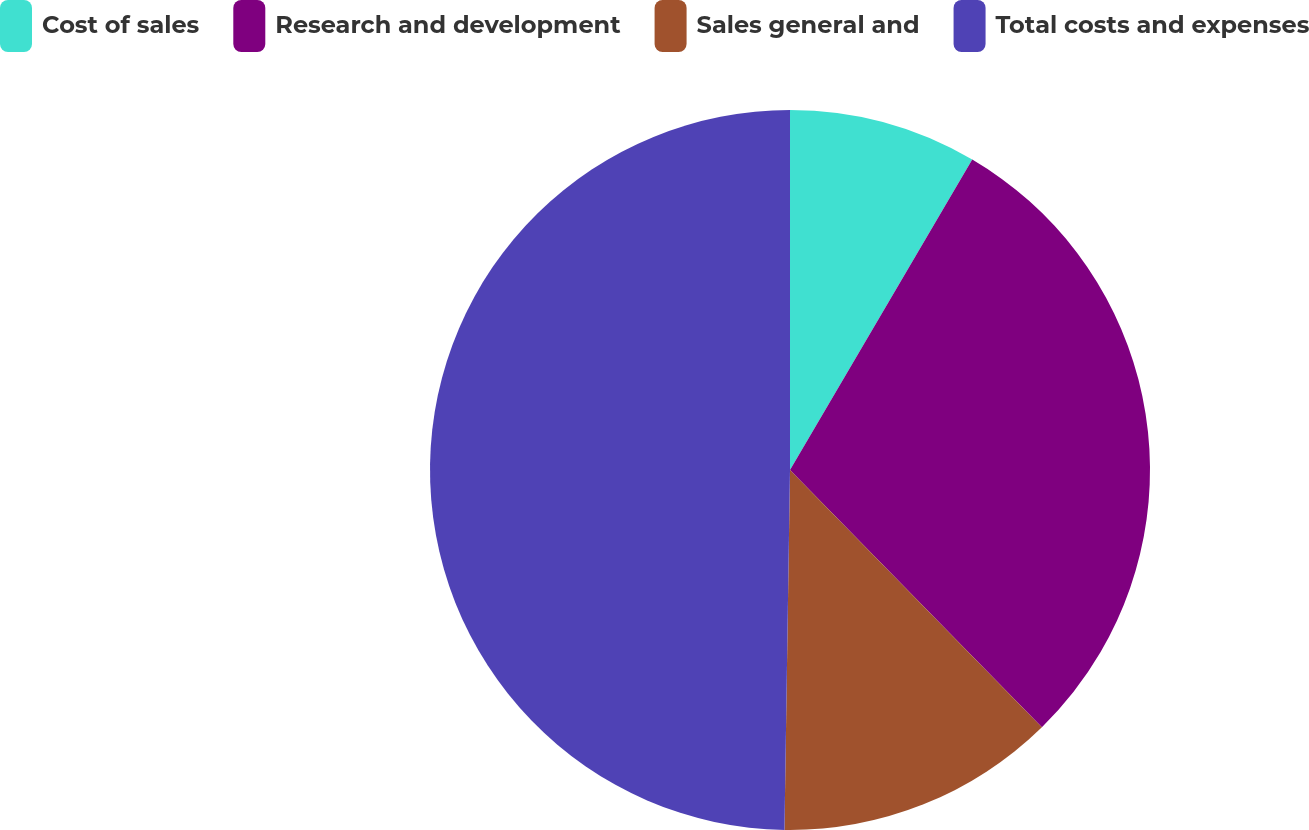<chart> <loc_0><loc_0><loc_500><loc_500><pie_chart><fcel>Cost of sales<fcel>Research and development<fcel>Sales general and<fcel>Total costs and expenses<nl><fcel>8.45%<fcel>29.22%<fcel>12.58%<fcel>49.76%<nl></chart> 